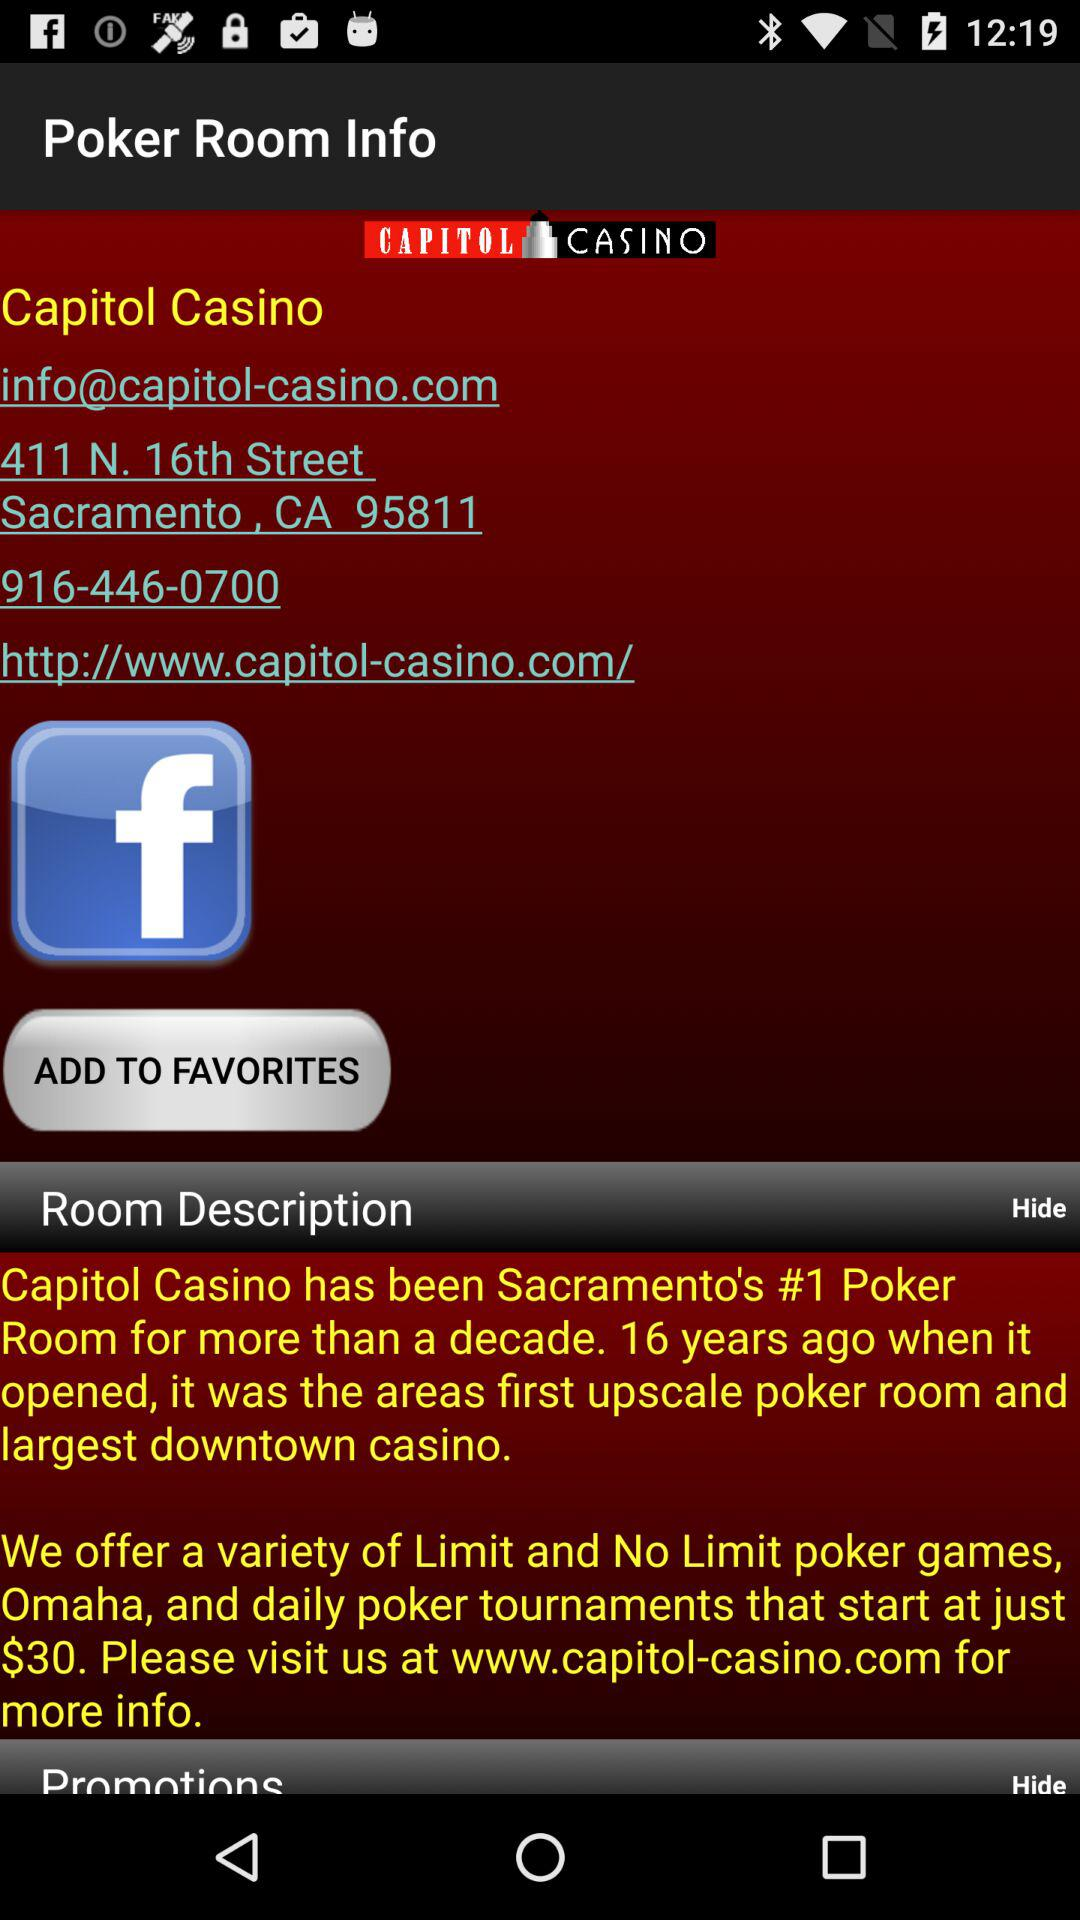What is the address? The address is "411 N. 16th Street Sacramento, CA 95811". 